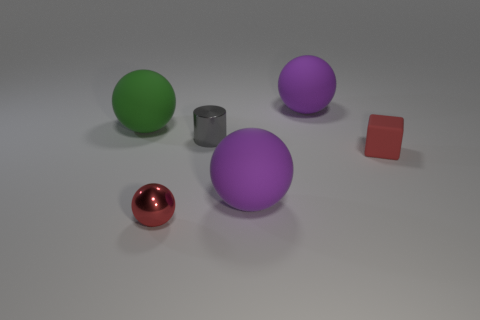Subtract all cyan balls. Subtract all blue cylinders. How many balls are left? 4 Add 4 gray metal objects. How many objects exist? 10 Subtract all cylinders. How many objects are left? 5 Subtract all small balls. Subtract all purple things. How many objects are left? 3 Add 6 large purple objects. How many large purple objects are left? 8 Add 4 small shiny cylinders. How many small shiny cylinders exist? 5 Subtract 0 gray cubes. How many objects are left? 6 